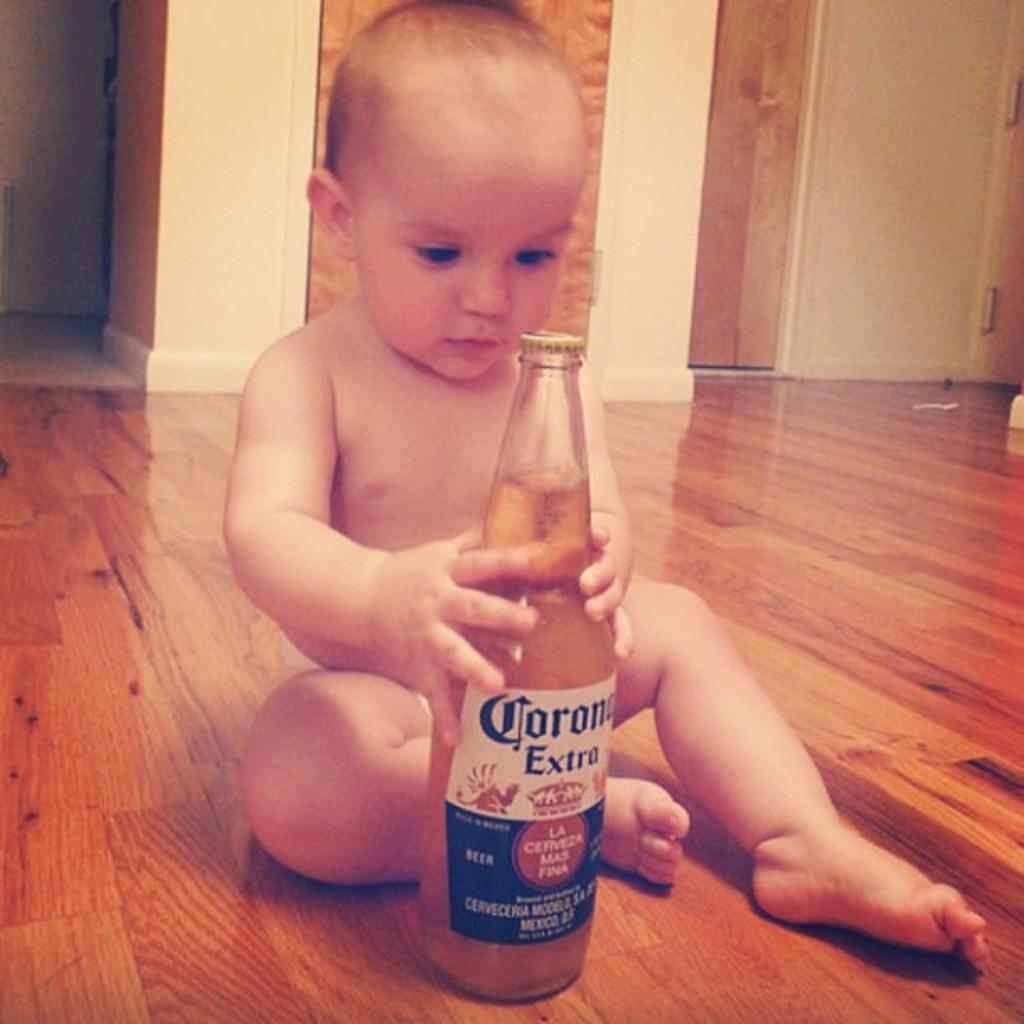What is the position of the kid in the image? The kid is sitting on the floor. What is the kid holding in the image? The kid is holding a bottle. What can be seen in the background of the image? There is a wall in the background of the image. What type of education is the kid attending in the image? There is no indication of education in the image; it simply shows a kid sitting on the floor holding a bottle. What is the kid protesting about in the image? There is no protest or any indication of a protest in the image. 